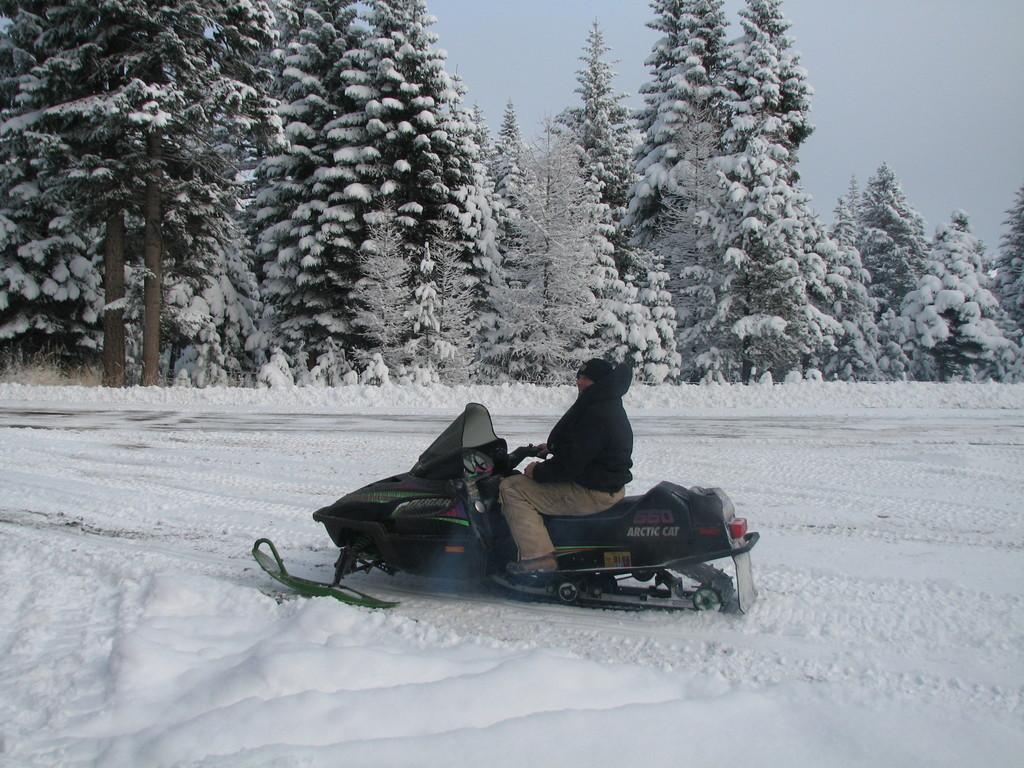What is the person in the image doing? The person is on a vehicle in the image. What is the condition of the ground in the image? The ground is covered with snow. What type of natural environment can be seen in the image? There are trees in the image. What is visible in the background of the image? The sky is visible in the image. What type of headwear is the fowl wearing in the image? There is no fowl present in the image, so it is not possible to determine what type of headwear it might be wearing. 